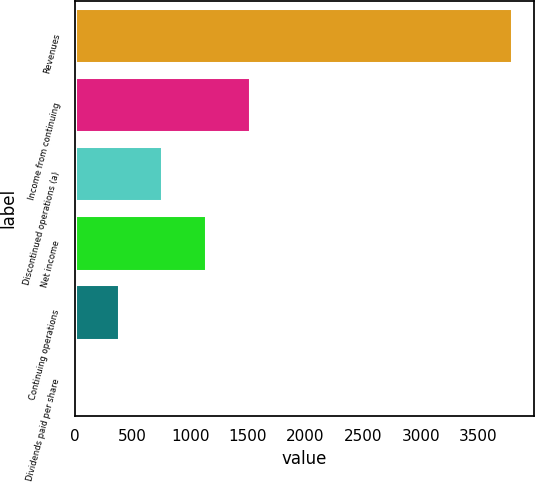<chart> <loc_0><loc_0><loc_500><loc_500><bar_chart><fcel>Revenues<fcel>Income from continuing<fcel>Discontinued operations (a)<fcel>Net income<fcel>Continuing operations<fcel>Dividends paid per share<nl><fcel>3793<fcel>1517.29<fcel>758.73<fcel>1138.01<fcel>379.45<fcel>0.17<nl></chart> 